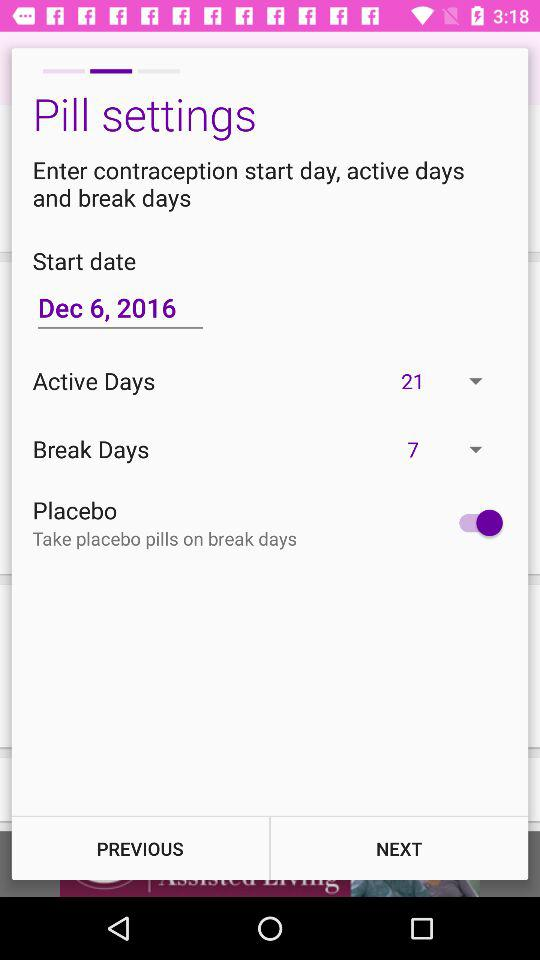How many days are available for a break? The days for a break are 7. 